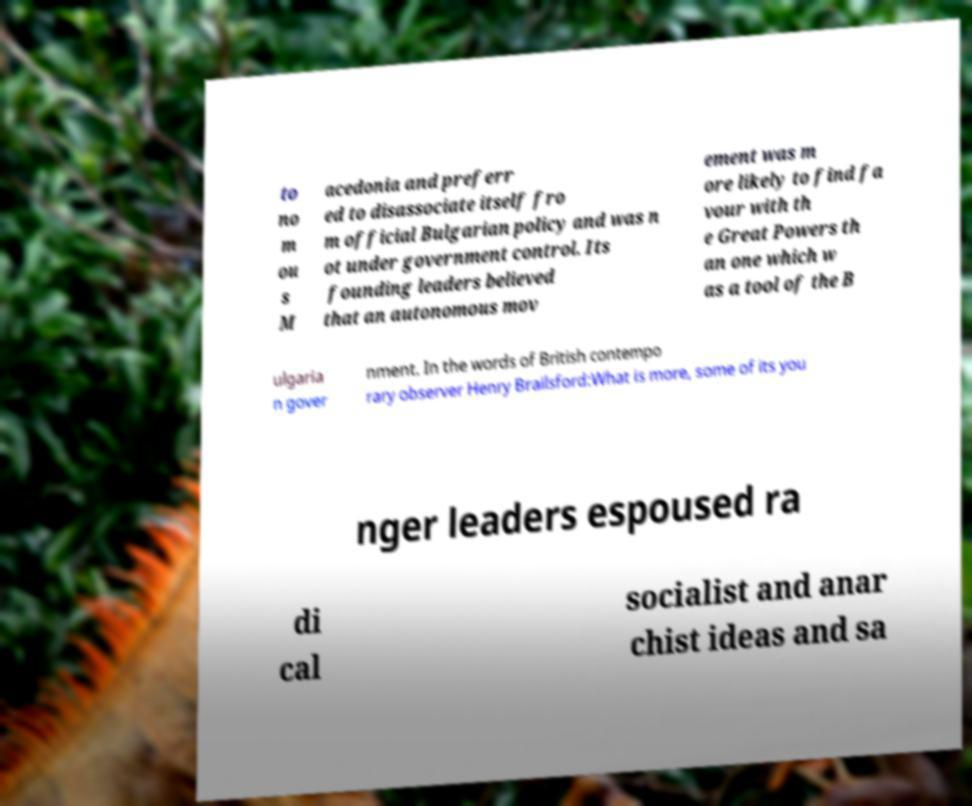Can you accurately transcribe the text from the provided image for me? to no m ou s M acedonia and preferr ed to disassociate itself fro m official Bulgarian policy and was n ot under government control. Its founding leaders believed that an autonomous mov ement was m ore likely to find fa vour with th e Great Powers th an one which w as a tool of the B ulgaria n gover nment. In the words of British contempo rary observer Henry Brailsford:What is more, some of its you nger leaders espoused ra di cal socialist and anar chist ideas and sa 